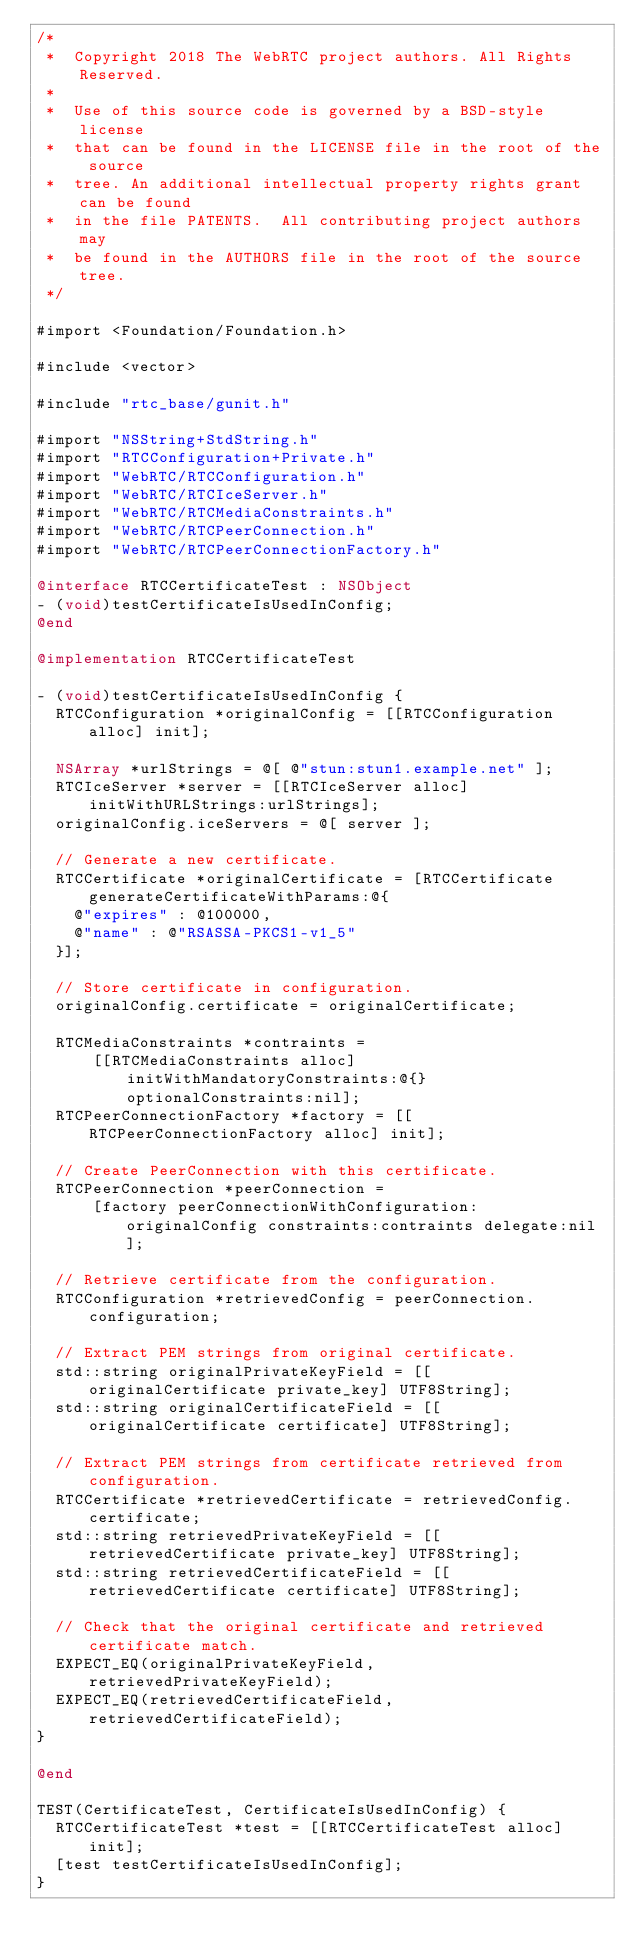<code> <loc_0><loc_0><loc_500><loc_500><_ObjectiveC_>/*
 *  Copyright 2018 The WebRTC project authors. All Rights Reserved.
 *
 *  Use of this source code is governed by a BSD-style license
 *  that can be found in the LICENSE file in the root of the source
 *  tree. An additional intellectual property rights grant can be found
 *  in the file PATENTS.  All contributing project authors may
 *  be found in the AUTHORS file in the root of the source tree.
 */

#import <Foundation/Foundation.h>

#include <vector>

#include "rtc_base/gunit.h"

#import "NSString+StdString.h"
#import "RTCConfiguration+Private.h"
#import "WebRTC/RTCConfiguration.h"
#import "WebRTC/RTCIceServer.h"
#import "WebRTC/RTCMediaConstraints.h"
#import "WebRTC/RTCPeerConnection.h"
#import "WebRTC/RTCPeerConnectionFactory.h"

@interface RTCCertificateTest : NSObject
- (void)testCertificateIsUsedInConfig;
@end

@implementation RTCCertificateTest

- (void)testCertificateIsUsedInConfig {
  RTCConfiguration *originalConfig = [[RTCConfiguration alloc] init];

  NSArray *urlStrings = @[ @"stun:stun1.example.net" ];
  RTCIceServer *server = [[RTCIceServer alloc] initWithURLStrings:urlStrings];
  originalConfig.iceServers = @[ server ];

  // Generate a new certificate.
  RTCCertificate *originalCertificate = [RTCCertificate generateCertificateWithParams:@{
    @"expires" : @100000,
    @"name" : @"RSASSA-PKCS1-v1_5"
  }];

  // Store certificate in configuration.
  originalConfig.certificate = originalCertificate;

  RTCMediaConstraints *contraints =
      [[RTCMediaConstraints alloc] initWithMandatoryConstraints:@{} optionalConstraints:nil];
  RTCPeerConnectionFactory *factory = [[RTCPeerConnectionFactory alloc] init];

  // Create PeerConnection with this certificate.
  RTCPeerConnection *peerConnection =
      [factory peerConnectionWithConfiguration:originalConfig constraints:contraints delegate:nil];

  // Retrieve certificate from the configuration.
  RTCConfiguration *retrievedConfig = peerConnection.configuration;

  // Extract PEM strings from original certificate.
  std::string originalPrivateKeyField = [[originalCertificate private_key] UTF8String];
  std::string originalCertificateField = [[originalCertificate certificate] UTF8String];

  // Extract PEM strings from certificate retrieved from configuration.
  RTCCertificate *retrievedCertificate = retrievedConfig.certificate;
  std::string retrievedPrivateKeyField = [[retrievedCertificate private_key] UTF8String];
  std::string retrievedCertificateField = [[retrievedCertificate certificate] UTF8String];

  // Check that the original certificate and retrieved certificate match.
  EXPECT_EQ(originalPrivateKeyField, retrievedPrivateKeyField);
  EXPECT_EQ(retrievedCertificateField, retrievedCertificateField);
}

@end

TEST(CertificateTest, CertificateIsUsedInConfig) {
  RTCCertificateTest *test = [[RTCCertificateTest alloc] init];
  [test testCertificateIsUsedInConfig];
}
</code> 